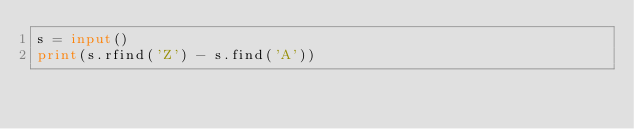Convert code to text. <code><loc_0><loc_0><loc_500><loc_500><_Python_>s = input()
print(s.rfind('Z') - s.find('A'))</code> 